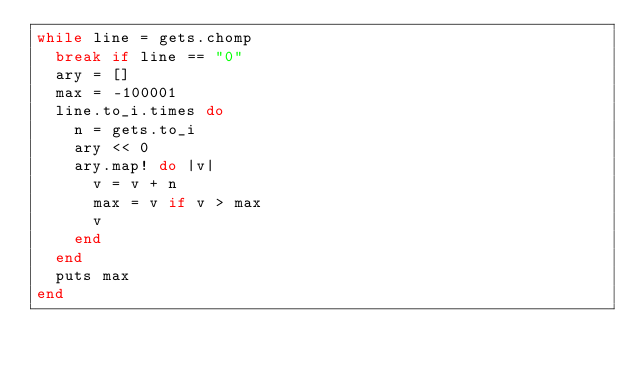Convert code to text. <code><loc_0><loc_0><loc_500><loc_500><_Ruby_>while line = gets.chomp
  break if line == "0"
  ary = []
  max = -100001
  line.to_i.times do
    n = gets.to_i
    ary << 0
    ary.map! do |v|
      v = v + n
      max = v if v > max
      v
    end
  end
  puts max
end</code> 